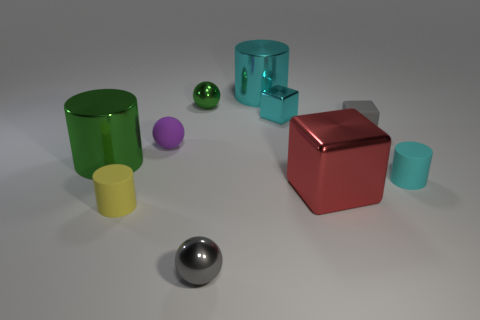Subtract all cylinders. How many objects are left? 6 Subtract all large green rubber cylinders. Subtract all tiny cyan cylinders. How many objects are left? 9 Add 7 small matte cylinders. How many small matte cylinders are left? 9 Add 4 large green shiny cylinders. How many large green shiny cylinders exist? 5 Subtract 0 purple cylinders. How many objects are left? 10 